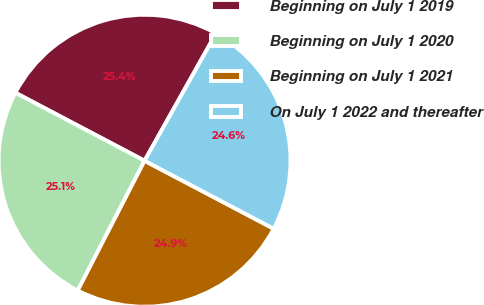Convert chart. <chart><loc_0><loc_0><loc_500><loc_500><pie_chart><fcel>Beginning on July 1 2019<fcel>Beginning on July 1 2020<fcel>Beginning on July 1 2021<fcel>On July 1 2022 and thereafter<nl><fcel>25.43%<fcel>25.14%<fcel>24.86%<fcel>24.57%<nl></chart> 